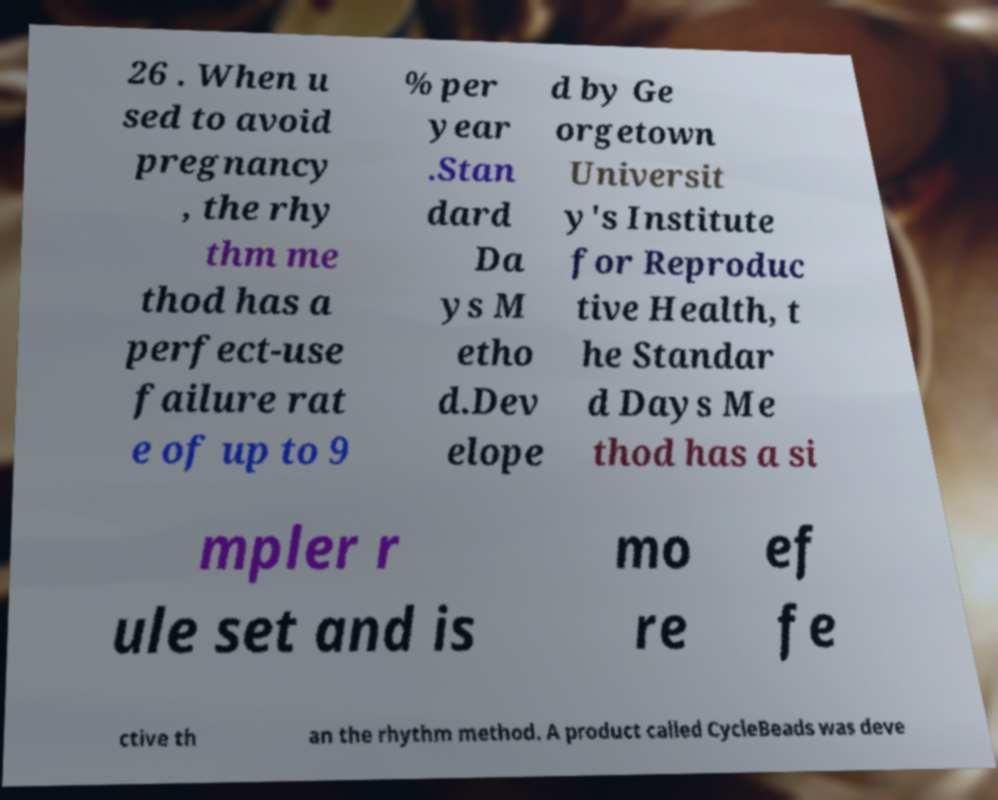There's text embedded in this image that I need extracted. Can you transcribe it verbatim? 26 . When u sed to avoid pregnancy , the rhy thm me thod has a perfect-use failure rat e of up to 9 % per year .Stan dard Da ys M etho d.Dev elope d by Ge orgetown Universit y's Institute for Reproduc tive Health, t he Standar d Days Me thod has a si mpler r ule set and is mo re ef fe ctive th an the rhythm method. A product called CycleBeads was deve 